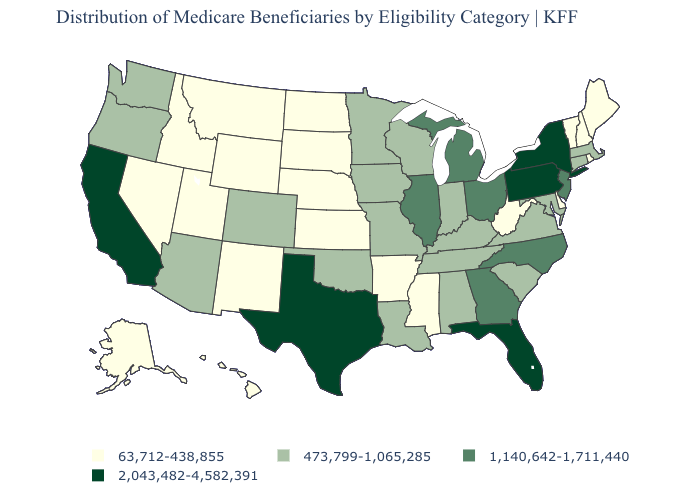Name the states that have a value in the range 2,043,482-4,582,391?
Answer briefly. California, Florida, New York, Pennsylvania, Texas. Name the states that have a value in the range 2,043,482-4,582,391?
Quick response, please. California, Florida, New York, Pennsylvania, Texas. Among the states that border Utah , which have the highest value?
Short answer required. Arizona, Colorado. Name the states that have a value in the range 473,799-1,065,285?
Short answer required. Alabama, Arizona, Colorado, Connecticut, Indiana, Iowa, Kentucky, Louisiana, Maryland, Massachusetts, Minnesota, Missouri, Oklahoma, Oregon, South Carolina, Tennessee, Virginia, Washington, Wisconsin. Name the states that have a value in the range 2,043,482-4,582,391?
Answer briefly. California, Florida, New York, Pennsylvania, Texas. What is the lowest value in the Northeast?
Concise answer only. 63,712-438,855. Name the states that have a value in the range 2,043,482-4,582,391?
Quick response, please. California, Florida, New York, Pennsylvania, Texas. Does the first symbol in the legend represent the smallest category?
Short answer required. Yes. Name the states that have a value in the range 2,043,482-4,582,391?
Quick response, please. California, Florida, New York, Pennsylvania, Texas. Name the states that have a value in the range 63,712-438,855?
Write a very short answer. Alaska, Arkansas, Delaware, Hawaii, Idaho, Kansas, Maine, Mississippi, Montana, Nebraska, Nevada, New Hampshire, New Mexico, North Dakota, Rhode Island, South Dakota, Utah, Vermont, West Virginia, Wyoming. What is the value of Alabama?
Short answer required. 473,799-1,065,285. What is the lowest value in the USA?
Give a very brief answer. 63,712-438,855. What is the highest value in the USA?
Be succinct. 2,043,482-4,582,391. Which states have the lowest value in the USA?
Give a very brief answer. Alaska, Arkansas, Delaware, Hawaii, Idaho, Kansas, Maine, Mississippi, Montana, Nebraska, Nevada, New Hampshire, New Mexico, North Dakota, Rhode Island, South Dakota, Utah, Vermont, West Virginia, Wyoming. Does the map have missing data?
Write a very short answer. No. 